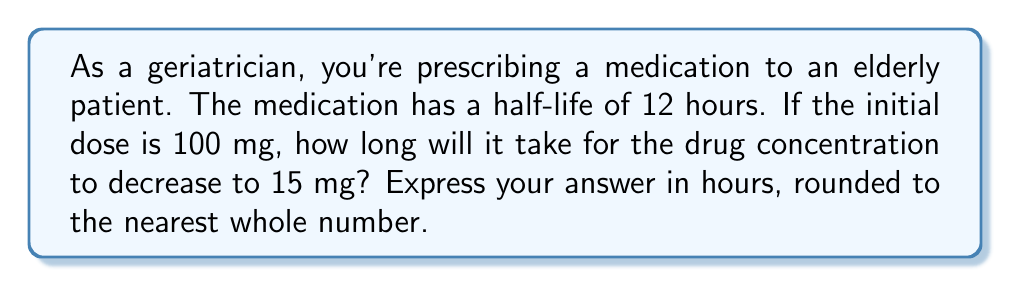Can you answer this question? To solve this problem, we'll use the exponential decay formula and logarithms:

1) The exponential decay formula is:
   $$ A(t) = A_0 \cdot (\frac{1}{2})^{\frac{t}{t_{1/2}}} $$
   Where:
   $A(t)$ is the amount at time $t$
   $A_0$ is the initial amount
   $t$ is the time elapsed
   $t_{1/2}$ is the half-life

2) We know:
   $A_0 = 100$ mg
   $A(t) = 15$ mg
   $t_{1/2} = 12$ hours

3) Substituting these values:
   $$ 15 = 100 \cdot (\frac{1}{2})^{\frac{t}{12}} $$

4) Divide both sides by 100:
   $$ 0.15 = (\frac{1}{2})^{\frac{t}{12}} $$

5) Take the logarithm (base 2) of both sides:
   $$ \log_2(0.15) = \frac{t}{12} $$

6) Multiply both sides by 12:
   $$ 12 \cdot \log_2(0.15) = t $$

7) To calculate this:
   $$ t = 12 \cdot \frac{\ln(0.15)}{\ln(0.5)} \approx 32.54 \text{ hours} $$

8) Rounding to the nearest whole number:
   $t \approx 33$ hours
Answer: 33 hours 